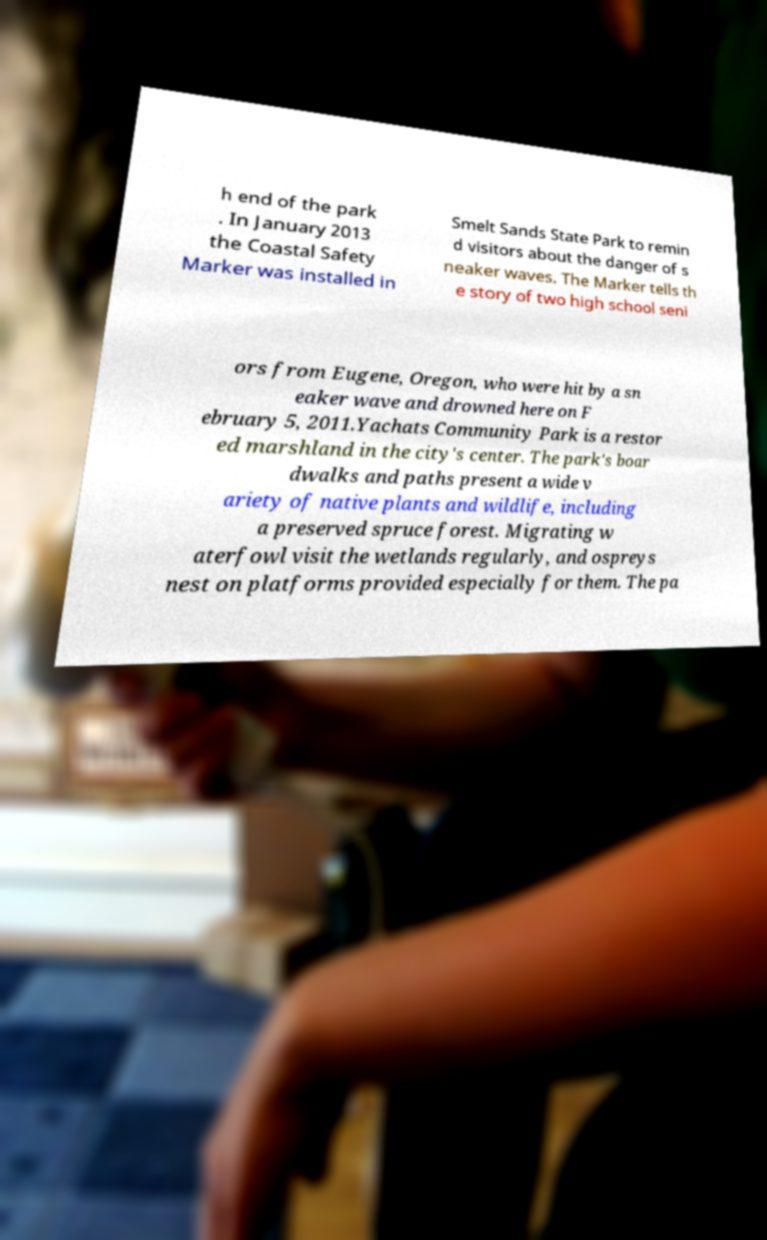For documentation purposes, I need the text within this image transcribed. Could you provide that? h end of the park . In January 2013 the Coastal Safety Marker was installed in Smelt Sands State Park to remin d visitors about the danger of s neaker waves. The Marker tells th e story of two high school seni ors from Eugene, Oregon, who were hit by a sn eaker wave and drowned here on F ebruary 5, 2011.Yachats Community Park is a restor ed marshland in the city's center. The park's boar dwalks and paths present a wide v ariety of native plants and wildlife, including a preserved spruce forest. Migrating w aterfowl visit the wetlands regularly, and ospreys nest on platforms provided especially for them. The pa 